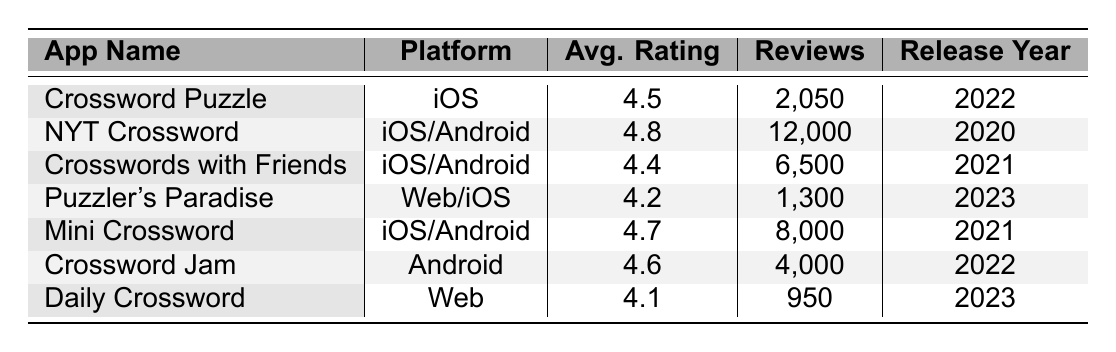What is the average rating of the NYT Crossword app? The NYT Crossword app has an average rating listed in the table, which is 4.8.
Answer: 4.8 Which app has the highest number of reviews? Referring to the table, NYT Crossword has the highest number of reviews at 12,000.
Answer: NYT Crossword How many reviews does Mini Crossword have compared to Daily Crossword? Mini Crossword has 8,000 reviews and Daily Crossword has 950 reviews. The difference is 8000 - 950 = 7050.
Answer: 7050 What percentage of reviews do the Puzzler's Paradise and Daily Crossword apps combined represent from the total reviews of all apps in the table? Adding the reviews of both apps gives us 1,300 (Puzzler's Paradise) + 950 (Daily Crossword) = 2,250. The total reviews for all apps is 38,350. The percentage is (2,250 / 38,350) * 100 ≈ 5.86%.
Answer: Approximately 5.86% Is the average rating of Crossword Jam higher than that of Daily Crossword? Comparing their ratings, Crossword Jam has an average rating of 4.6 while Daily Crossword has 4.1. 4.6 is higher, so the statement is true.
Answer: Yes Which apps were released in 2021? By scanning the release years in the table, Mini Crossword and Crosswords with Friends are the apps released in 2021.
Answer: Mini Crossword, Crosswords with Friends If we consider only iOS/Android apps, which one has the lowest average rating? Checking the iOS/Android apps, Crosswords with Friends has 4.4 while NYT Crossword has 4.8, and Mini Crossword has 4.7. Therefore, Crosswords with Friends has the lowest average rating among them.
Answer: Crosswords with Friends What is the difference in average ratings between the app with the highest rating and the app with the lowest rating? The highest average rating is for NYT Crossword at 4.8 and the lowest rating is for Daily Crossword at 4.1. The difference is 4.8 - 4.1 = 0.7.
Answer: 0.7 How many total reviews do all the apps have combined? Summing the reviews gives us 2,050 + 12,000 + 6,500 + 1,300 + 8,000 + 4,000 + 950 = 34,800.
Answer: 34,800 Are there any apps released in 2022 with an average rating below 4.5? The table shows Crossword Puzzle (4.5) and Crossword Jam (4.6) both released in 2022, and both have ratings that are not below 4.5.
Answer: No Which platform has the highest average rating among the apps listed? The highest average rating is for NYT Crossword (4.8), which is available on iOS/Android. Thus, iOS/Android has the highest average rating among the platforms.
Answer: iOS/Android 